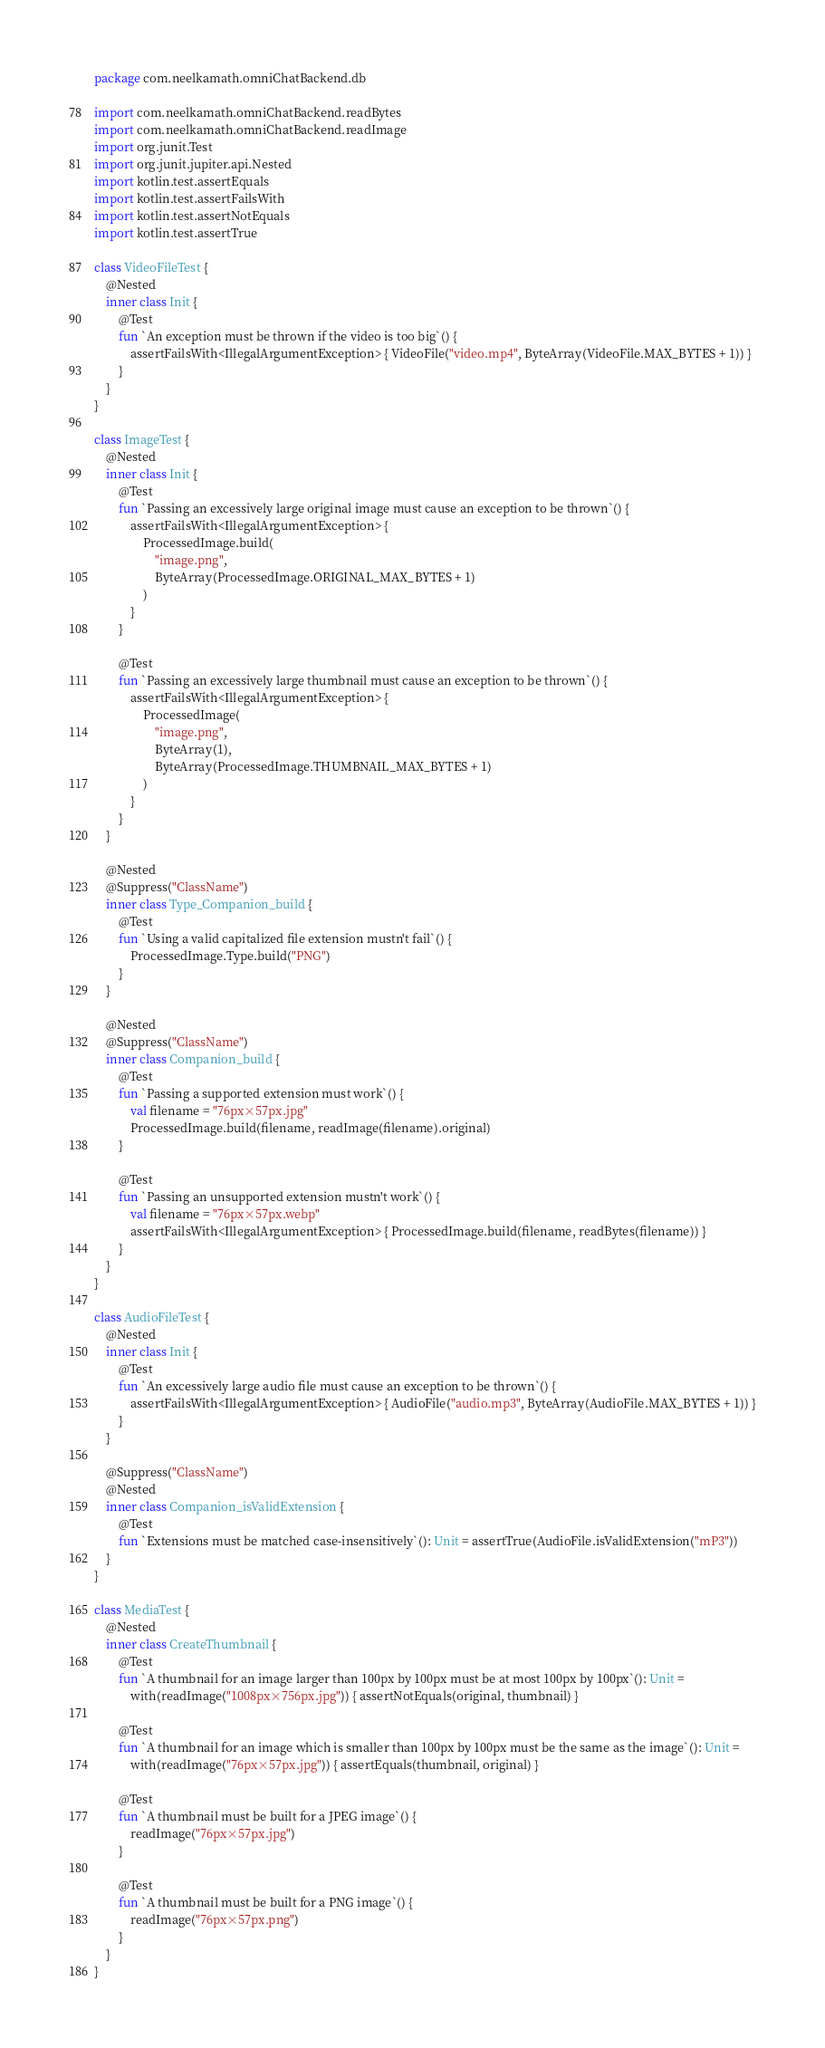<code> <loc_0><loc_0><loc_500><loc_500><_Kotlin_>package com.neelkamath.omniChatBackend.db

import com.neelkamath.omniChatBackend.readBytes
import com.neelkamath.omniChatBackend.readImage
import org.junit.Test
import org.junit.jupiter.api.Nested
import kotlin.test.assertEquals
import kotlin.test.assertFailsWith
import kotlin.test.assertNotEquals
import kotlin.test.assertTrue

class VideoFileTest {
    @Nested
    inner class Init {
        @Test
        fun `An exception must be thrown if the video is too big`() {
            assertFailsWith<IllegalArgumentException> { VideoFile("video.mp4", ByteArray(VideoFile.MAX_BYTES + 1)) }
        }
    }
}

class ImageTest {
    @Nested
    inner class Init {
        @Test
        fun `Passing an excessively large original image must cause an exception to be thrown`() {
            assertFailsWith<IllegalArgumentException> {
                ProcessedImage.build(
                    "image.png",
                    ByteArray(ProcessedImage.ORIGINAL_MAX_BYTES + 1)
                )
            }
        }

        @Test
        fun `Passing an excessively large thumbnail must cause an exception to be thrown`() {
            assertFailsWith<IllegalArgumentException> {
                ProcessedImage(
                    "image.png",
                    ByteArray(1),
                    ByteArray(ProcessedImage.THUMBNAIL_MAX_BYTES + 1)
                )
            }
        }
    }

    @Nested
    @Suppress("ClassName")
    inner class Type_Companion_build {
        @Test
        fun `Using a valid capitalized file extension mustn't fail`() {
            ProcessedImage.Type.build("PNG")
        }
    }

    @Nested
    @Suppress("ClassName")
    inner class Companion_build {
        @Test
        fun `Passing a supported extension must work`() {
            val filename = "76px×57px.jpg"
            ProcessedImage.build(filename, readImage(filename).original)
        }

        @Test
        fun `Passing an unsupported extension mustn't work`() {
            val filename = "76px×57px.webp"
            assertFailsWith<IllegalArgumentException> { ProcessedImage.build(filename, readBytes(filename)) }
        }
    }
}

class AudioFileTest {
    @Nested
    inner class Init {
        @Test
        fun `An excessively large audio file must cause an exception to be thrown`() {
            assertFailsWith<IllegalArgumentException> { AudioFile("audio.mp3", ByteArray(AudioFile.MAX_BYTES + 1)) }
        }
    }

    @Suppress("ClassName")
    @Nested
    inner class Companion_isValidExtension {
        @Test
        fun `Extensions must be matched case-insensitively`(): Unit = assertTrue(AudioFile.isValidExtension("mP3"))
    }
}

class MediaTest {
    @Nested
    inner class CreateThumbnail {
        @Test
        fun `A thumbnail for an image larger than 100px by 100px must be at most 100px by 100px`(): Unit =
            with(readImage("1008px×756px.jpg")) { assertNotEquals(original, thumbnail) }

        @Test
        fun `A thumbnail for an image which is smaller than 100px by 100px must be the same as the image`(): Unit =
            with(readImage("76px×57px.jpg")) { assertEquals(thumbnail, original) }

        @Test
        fun `A thumbnail must be built for a JPEG image`() {
            readImage("76px×57px.jpg")
        }

        @Test
        fun `A thumbnail must be built for a PNG image`() {
            readImage("76px×57px.png")
        }
    }
}
</code> 